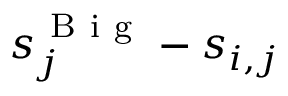<formula> <loc_0><loc_0><loc_500><loc_500>s _ { j } ^ { B i g } - s _ { i , j }</formula> 